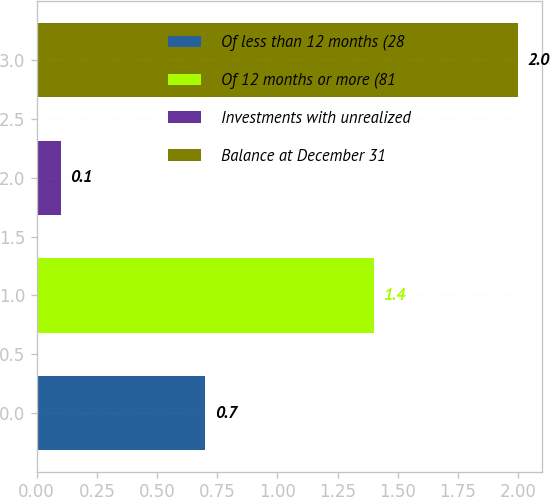Convert chart to OTSL. <chart><loc_0><loc_0><loc_500><loc_500><bar_chart><fcel>Of less than 12 months (28<fcel>Of 12 months or more (81<fcel>Investments with unrealized<fcel>Balance at December 31<nl><fcel>0.7<fcel>1.4<fcel>0.1<fcel>2<nl></chart> 